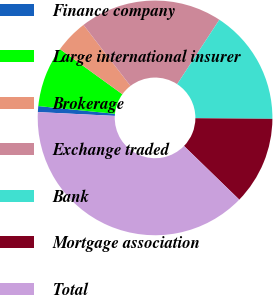Convert chart. <chart><loc_0><loc_0><loc_500><loc_500><pie_chart><fcel>Finance company<fcel>Large international insurer<fcel>Brokerage<fcel>Exchange traded<fcel>Bank<fcel>Mortgage association<fcel>Total<nl><fcel>0.82%<fcel>8.36%<fcel>4.59%<fcel>19.67%<fcel>15.9%<fcel>12.13%<fcel>38.52%<nl></chart> 